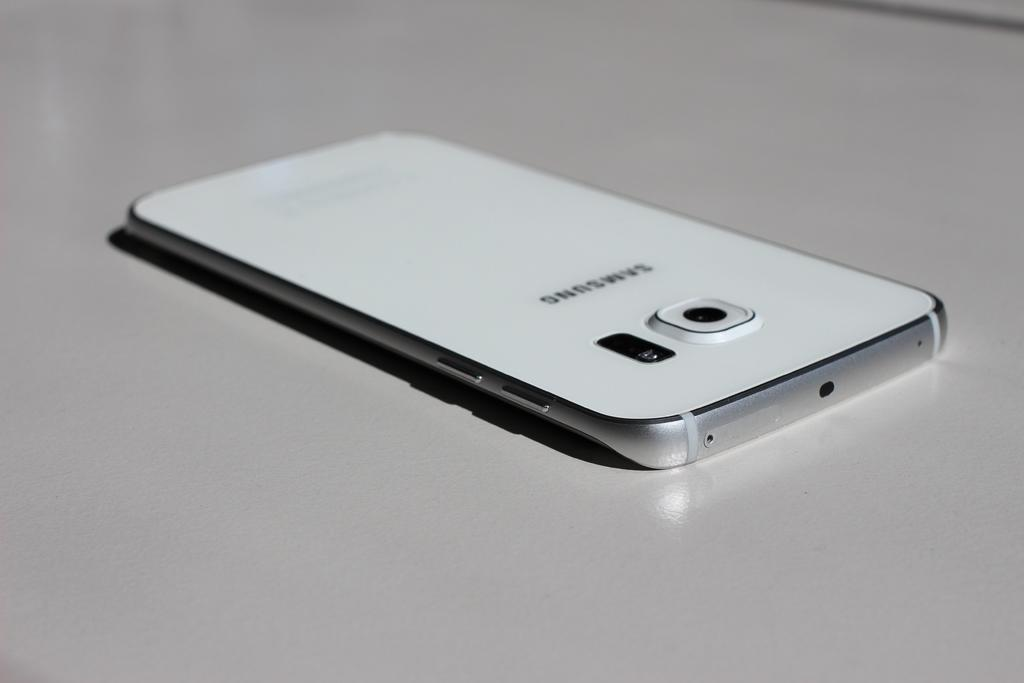<image>
Relay a brief, clear account of the picture shown. Back of a samsung smartphone that has a camera and light. 